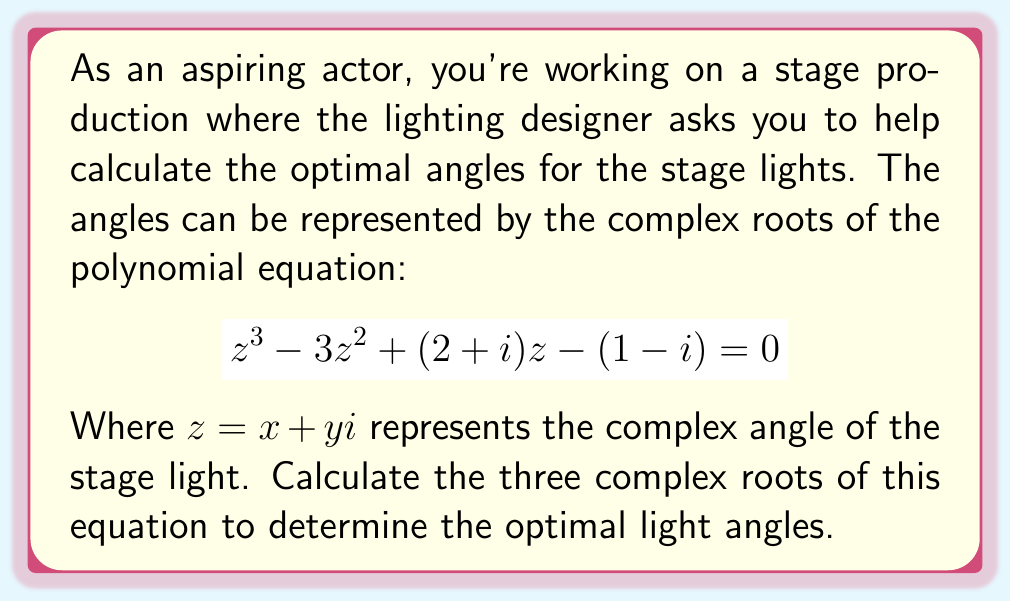What is the answer to this math problem? To solve this cubic equation, we'll use the following steps:

1) First, we need to put the equation in the standard form:
   $$z^3 + az^2 + bz + c = 0$$
   Where $a = -3$, $b = 2+i$, and $c = -(1-i) = -1+i$

2) We'll use Cardano's formula. Let's define:
   $$p = b - \frac{a^2}{3} = (2+i) - \frac{(-3)^2}{3} = 2+i-3 = -1+i$$
   $$q = c + \frac{2a^3}{27} - \frac{ab}{3} = (-1+i) + \frac{2(-3)^3}{27} - \frac{-3(2+i)}{3} = -1+i-2+2+i = i$$

3) Now, we calculate:
   $$D = \frac{q^2}{4} + \frac{p^3}{27} = \frac{i^2}{4} + \frac{(-1+i)^3}{27} = -\frac{1}{4} + \frac{-1-3i+3i-i^3}{27} = -\frac{1}{4} + \frac{-2}{27} = -\frac{27}{108} - \frac{8}{108} = -\frac{35}{108}$$

4) We then calculate:
   $$u = \sqrt[3]{-\frac{q}{2} + \sqrt{D}} = \sqrt[3]{-\frac{i}{2} + \sqrt{-\frac{35}{108}}} \approx 0.3090 + 0.9511i$$
   $$v = \sqrt[3]{-\frac{q}{2} - \sqrt{D}} = \sqrt[3]{-\frac{i}{2} - \sqrt{-\frac{35}{108}}} \approx -0.8090 + 0.5878i$$

5) The three roots are then given by:
   $$z_1 = u + v - \frac{a}{3}$$
   $$z_2 = \omega u + \omega^2 v - \frac{a}{3}$$
   $$z_3 = \omega^2 u + \omega v - \frac{a}{3}$$

   Where $\omega = -\frac{1}{2} + i\frac{\sqrt{3}}{2}$ is a cube root of unity.

6) Calculating these values:
   $$z_1 \approx 1.5000 + 1.5388i$$
   $$z_2 \approx 0.2500 - 1.3263i$$
   $$z_3 \approx 1.2500 - 0.2125i$$
Answer: The three complex roots are:
$$z_1 \approx 1.5000 + 1.5388i$$
$$z_2 \approx 0.2500 - 1.3263i$$
$$z_3 \approx 1.2500 - 0.2125i$$
These represent the optimal complex angles for the stage lights. 